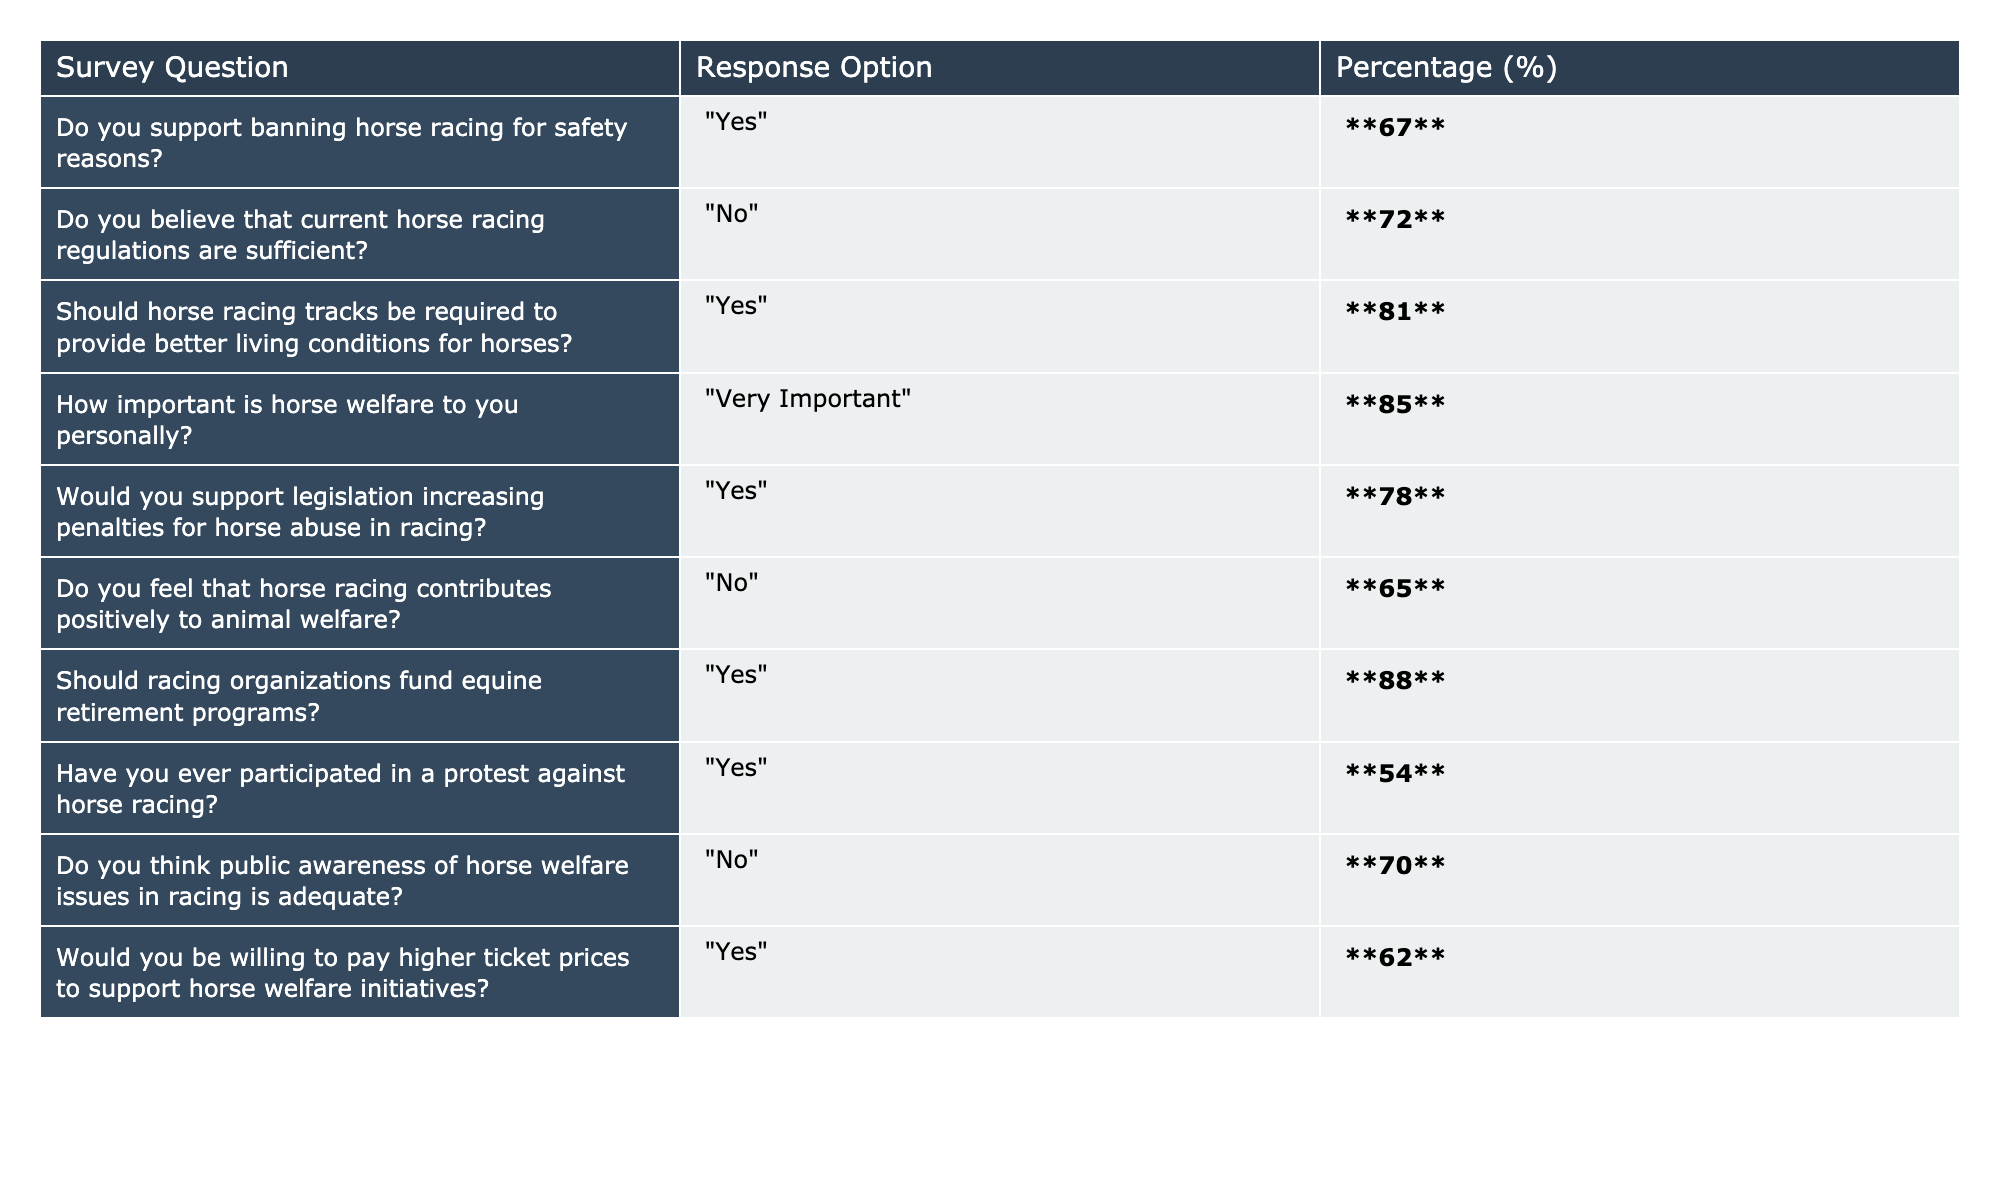What percentage of people support banning horse racing for safety reasons? The table indicates that **67**% of respondents support banning horse racing for safety reasons.
Answer: 67% How many respondents believe that current horse racing regulations are insufficient? According to the table, **72**% of respondents think that current regulations are not sufficient.
Answer: 72% What is the percentage of people who think horse racing tracks should provide better living conditions for horses? The table shows that **81**% of respondents believe horse racing tracks should provide better living conditions for horses.
Answer: 81% How important is horse welfare to the respondents personally? The data reveals that **85**% of respondents regard horse welfare as "Very Important".
Answer: 85% Would a majority support legislation increasing penalties for horse abuse in racing? Yes, **78**% of respondents would support legislation to increase penalties for horse abuse in racing, which indicates a majority.
Answer: Yes Is there a higher percentage of respondents who believe current horse racing regulations are sufficient compared to those who do not? No, **72**% believe the regulations are insufficient while only **28**% think they are sufficient, meaning the majority does not support the current regulations.
Answer: No What percentage of people feel that horse racing contributes positively to animal welfare? The table shows that **65**% of respondents feel that horse racing does not contribute positively to animal welfare, indicating that they believe it has a negative impact.
Answer: 65% What percentage of surveyed individuals support racing organizations funding equine retirement programs? The survey results indicate that **88**% of respondents support racing organizations funding equine retirement programs.
Answer: 88% If you combine the support for better living conditions for horses and the support for penalties for horse abuse, what is the total percentage of support? The combined support is **81**% (better living conditions) + **78**% (increasing penalties) = **159**%. This represents a significant level of support among respondents for both issues.
Answer: 159% Is it true that a greater percentage of respondents have participated in a protest against horse racing than those who think public awareness of horse welfare issues is adequate? Yes, **54**% have participated in a protest against horse racing, while only **30**% think public awareness is adequate, making it true that more have protested.
Answer: Yes 